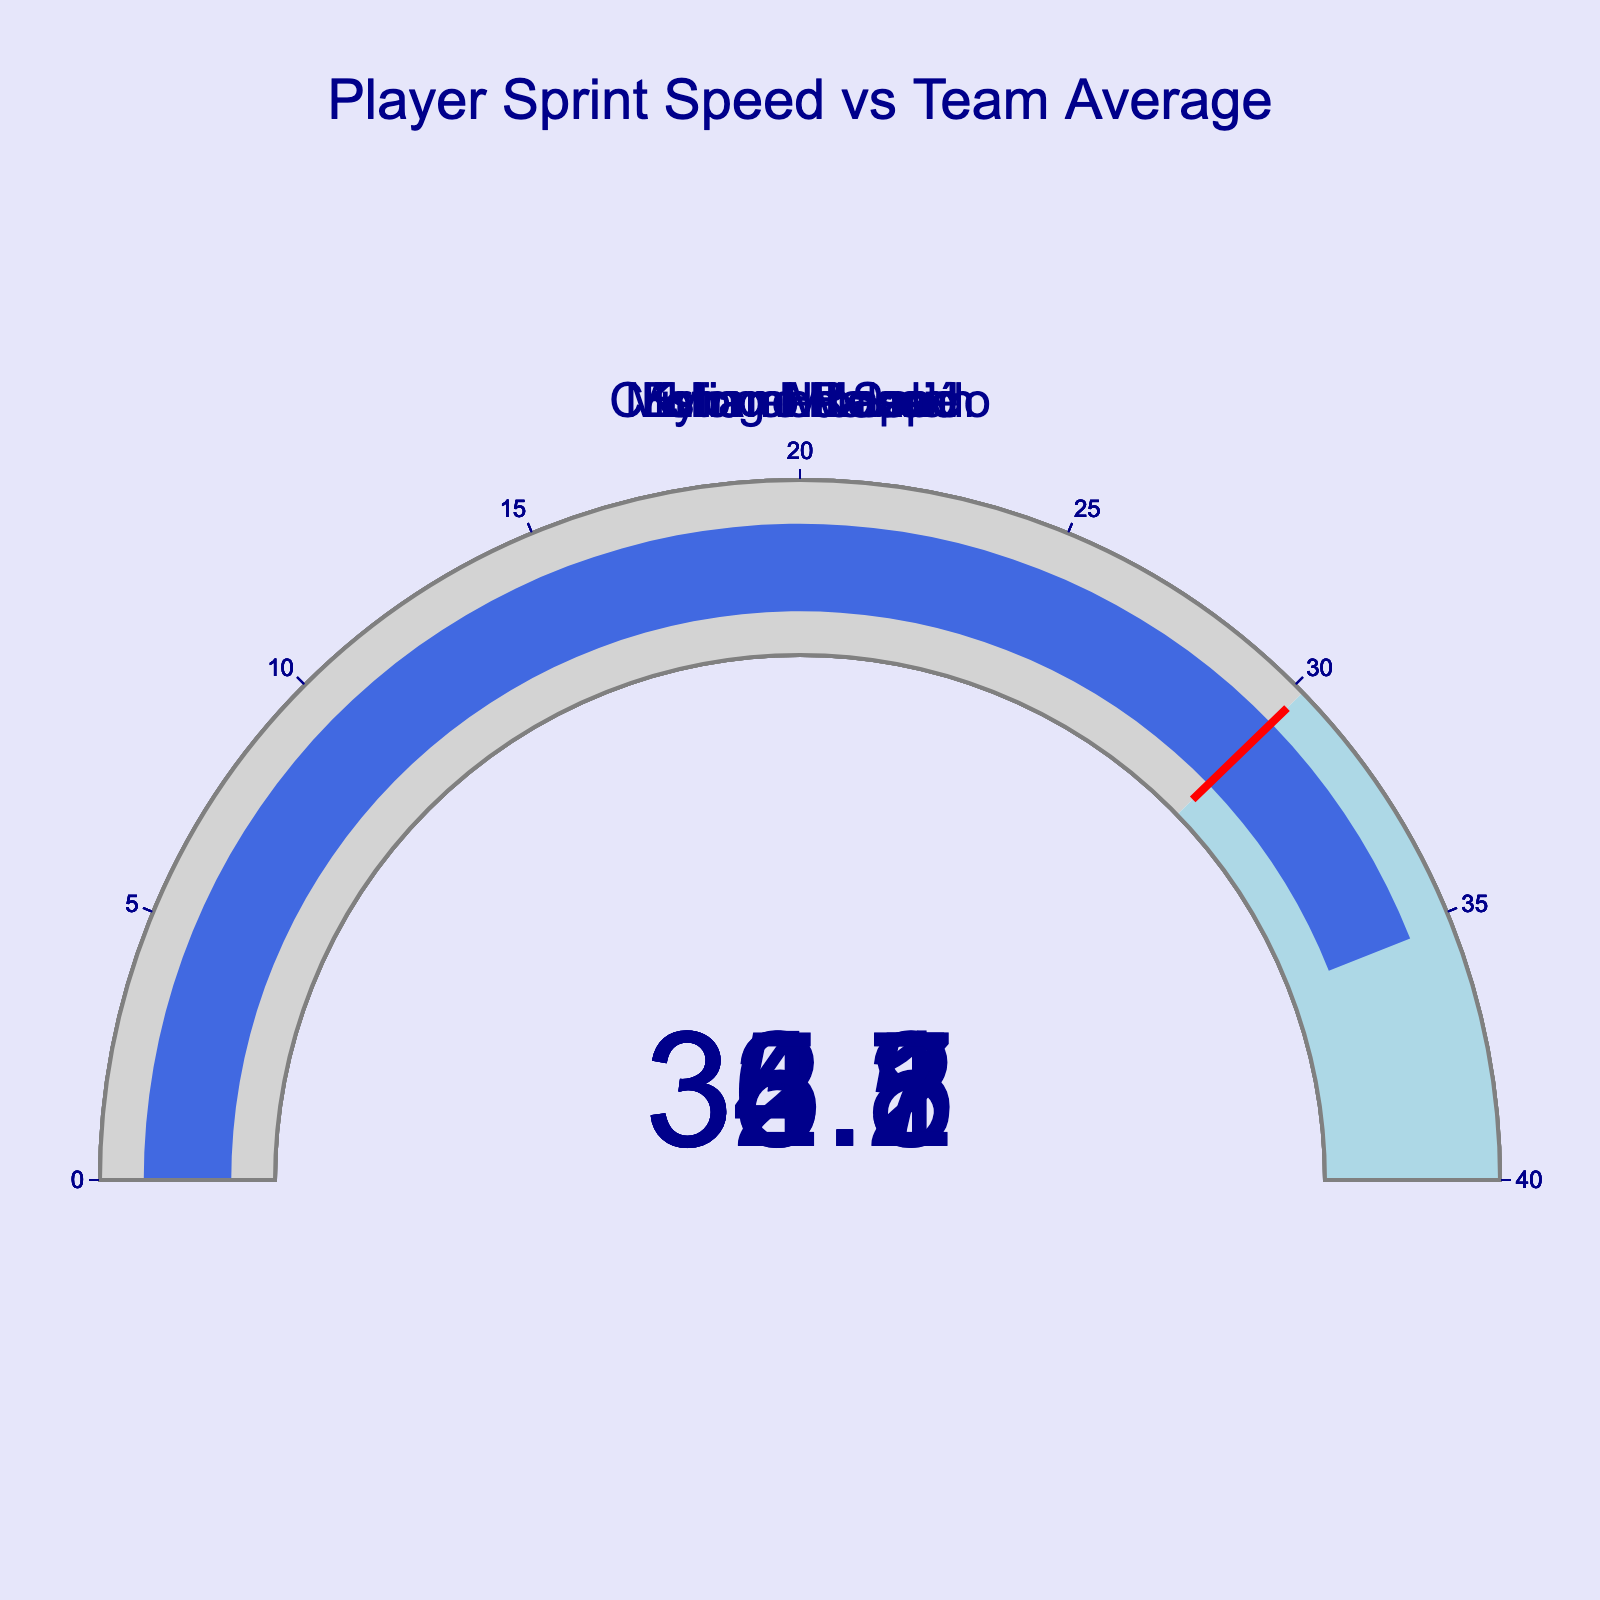What's the highest sprint speed shown in the figure? Looking at the gauge charts, identify the one with the highest value displayed. The highest sprint speed among the players is 36.1.
Answer: 36.1 How many players have a sprint speed higher than the team average? Compare the sprint speeds displayed in each gauge to the team average of 30.2. Count how many of these speeds are greater than 30.2. All five players have speeds greater than the team average.
Answer: 5 Which player has the lowest sprint speed? Identify the gauge with the lowest speed value displayed. The gauge for Lionel Messi has the lowest value at 32.5.
Answer: Lionel Messi What's the difference between Kylian Mbappé's and Cristiano Ronaldo's sprint speeds? Subtract Cristiano Ronaldo's speed from Kylian Mbappé's speed: 36.1 - 33.8 = 2.3.
Answer: 2.3 Which player has the sprint speed closest to the team average? Find the player whose sprint speed is nearest to 30.2 by calculating the differences and comparing: Messi (32.5-30.2 = 2.3), Ronaldo (33.8-30.2 = 3.6), Mbappé (36.1-30.2 = 5.9), Haaland (34.7-30.2 = 4.5), Salah (35.2-30.2 = 5.0). The closest is Lionel Messi at 2.3.
Answer: Lionel Messi What's the average sprint speed of the players? Add up all the players' sprint speeds and divide by the number of players: (32.5 + 33.8 + 36.1 + 34.7 + 35.2) / 5. The average is 34.46.
Answer: 34.46 Do any players have a sprint speed within 5 units of the team average? Check each player's speed to see if it's within 5 units of 30.2: Messi (32.5), Ronaldo (33.8), Mbappé (36.1), Haaland (34.7), Salah (35.2). All players' speeds are within this range.
Answer: Yes What's the range of sprint speeds among the players? Subtract the lowest speed from the highest speed: 36.1 - 32.5. The range is 3.6.
Answer: 3.6 Is Erling Haaland's sprint speed higher than Mohamed Salah's? Compare the values displayed on their respective gauges: Haaland (34.7) and Salah (35.2). Haaland's speed is lower.
Answer: No Which players have sprint speeds above 34? Identify the players whose gauges display speeds greater than 34: Ronaldo (33.8 is below), Mbappé (36.1), Haaland (34.7), Salah (35.2). The players are Mbappé, Haaland, and Salah.
Answer: Mbappé, Haaland, Salah 